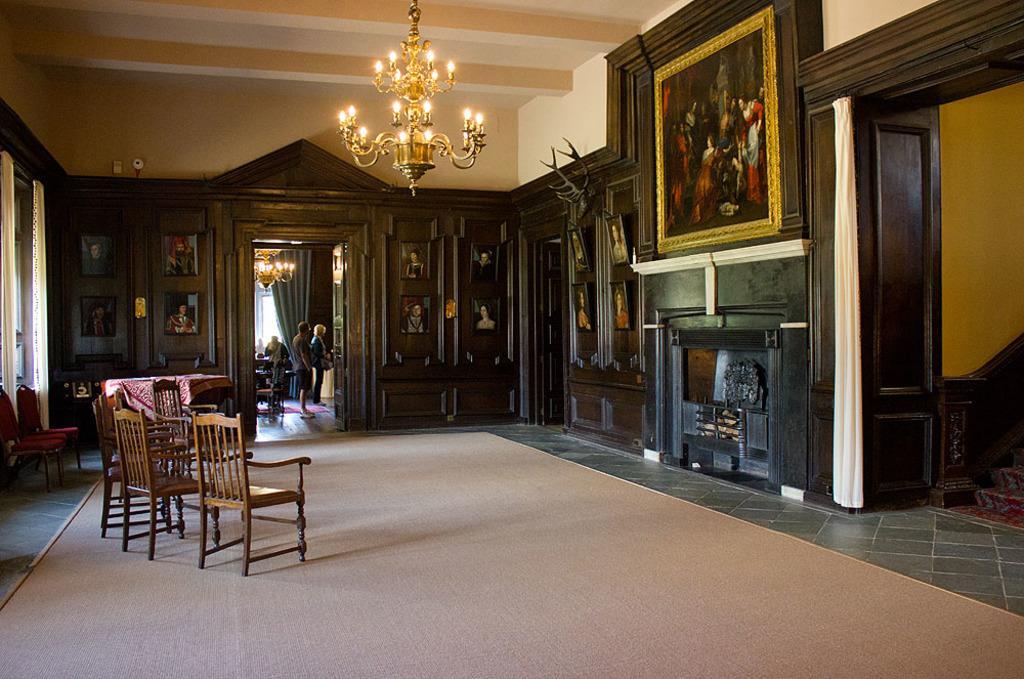Can you describe this image briefly? In this image we can see a room with a wall decorated with wood. There are some photo frames on the wall. On the left, we have curtains and chairs. In the middle we have a carpet and some more chairs. In the right bottom we have a staircase and in the background we have see some people. 